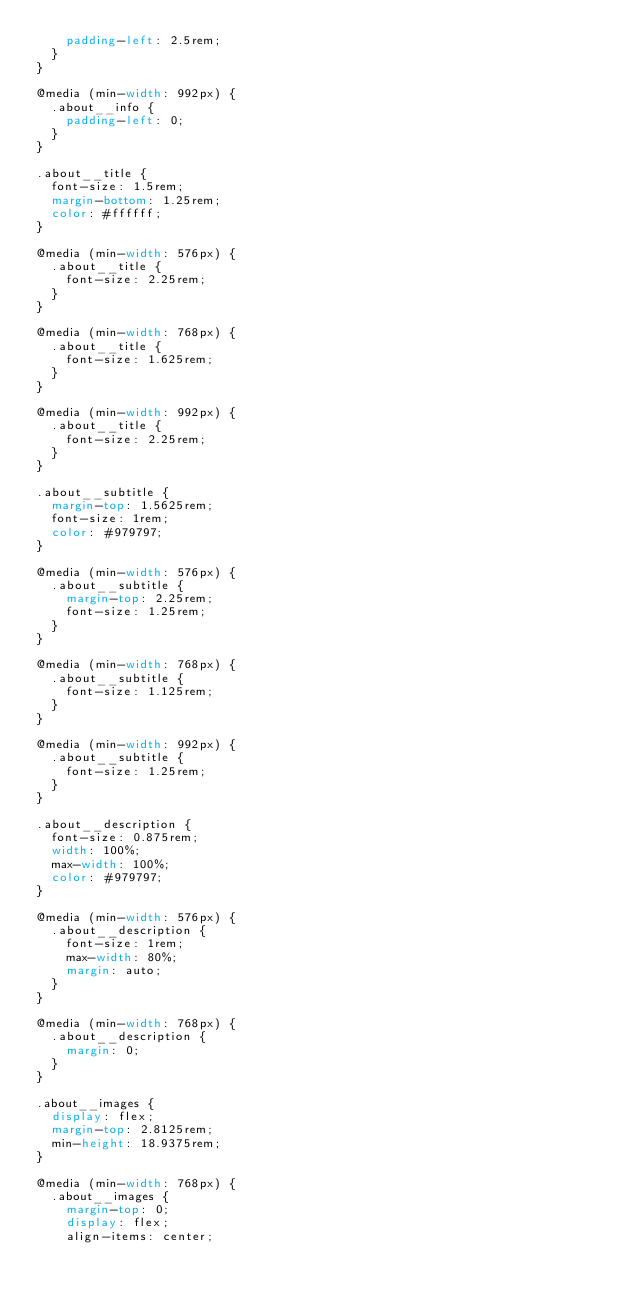<code> <loc_0><loc_0><loc_500><loc_500><_CSS_>    padding-left: 2.5rem;
  }
}

@media (min-width: 992px) {
  .about__info {
    padding-left: 0;
  }
}

.about__title {
  font-size: 1.5rem;
  margin-bottom: 1.25rem;
  color: #ffffff;
}

@media (min-width: 576px) {
  .about__title {
    font-size: 2.25rem;
  }
}

@media (min-width: 768px) {
  .about__title {
    font-size: 1.625rem;
  }
}

@media (min-width: 992px) {
  .about__title {
    font-size: 2.25rem;
  }
}

.about__subtitle {
  margin-top: 1.5625rem;
  font-size: 1rem;
  color: #979797;
}

@media (min-width: 576px) {
  .about__subtitle {
    margin-top: 2.25rem;
    font-size: 1.25rem;
  }
}

@media (min-width: 768px) {
  .about__subtitle {
    font-size: 1.125rem;
  }
}

@media (min-width: 992px) {
  .about__subtitle {
    font-size: 1.25rem;
  }
}

.about__description {
  font-size: 0.875rem;
  width: 100%;
  max-width: 100%;
  color: #979797;
}

@media (min-width: 576px) {
  .about__description {
    font-size: 1rem;
    max-width: 80%;
    margin: auto;
  }
}

@media (min-width: 768px) {
  .about__description {
    margin: 0;
  }
}

.about__images {
  display: flex;
  margin-top: 2.8125rem;
  min-height: 18.9375rem;
}

@media (min-width: 768px) {
  .about__images {
    margin-top: 0;
    display: flex;
    align-items: center;</code> 